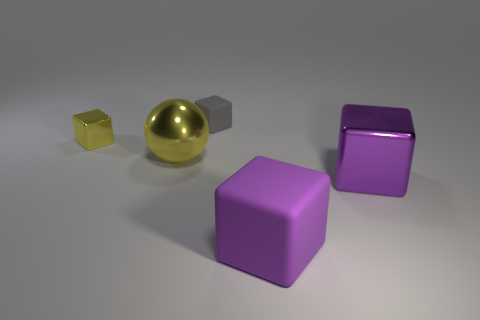How many large purple objects are behind the tiny metallic object?
Offer a terse response. 0. Is the size of the yellow object in front of the yellow cube the same as the rubber object that is to the right of the tiny matte cube?
Keep it short and to the point. Yes. How many other objects are the same size as the gray thing?
Ensure brevity in your answer.  1. There is a small cube that is left of the big metallic object that is behind the metal block right of the gray thing; what is its material?
Your answer should be compact. Metal. There is a purple rubber object; does it have the same size as the metal block to the right of the large metal ball?
Offer a terse response. Yes. How big is the cube that is both right of the small gray cube and behind the purple rubber thing?
Offer a very short reply. Large. Is there another big metal sphere of the same color as the ball?
Your answer should be very brief. No. There is a matte object behind the yellow metallic object that is in front of the small yellow thing; what is its color?
Make the answer very short. Gray. Is the number of big purple shiny objects left of the yellow cube less than the number of objects that are to the right of the small gray block?
Give a very brief answer. Yes. Does the gray rubber thing have the same size as the shiny ball?
Keep it short and to the point. No. 